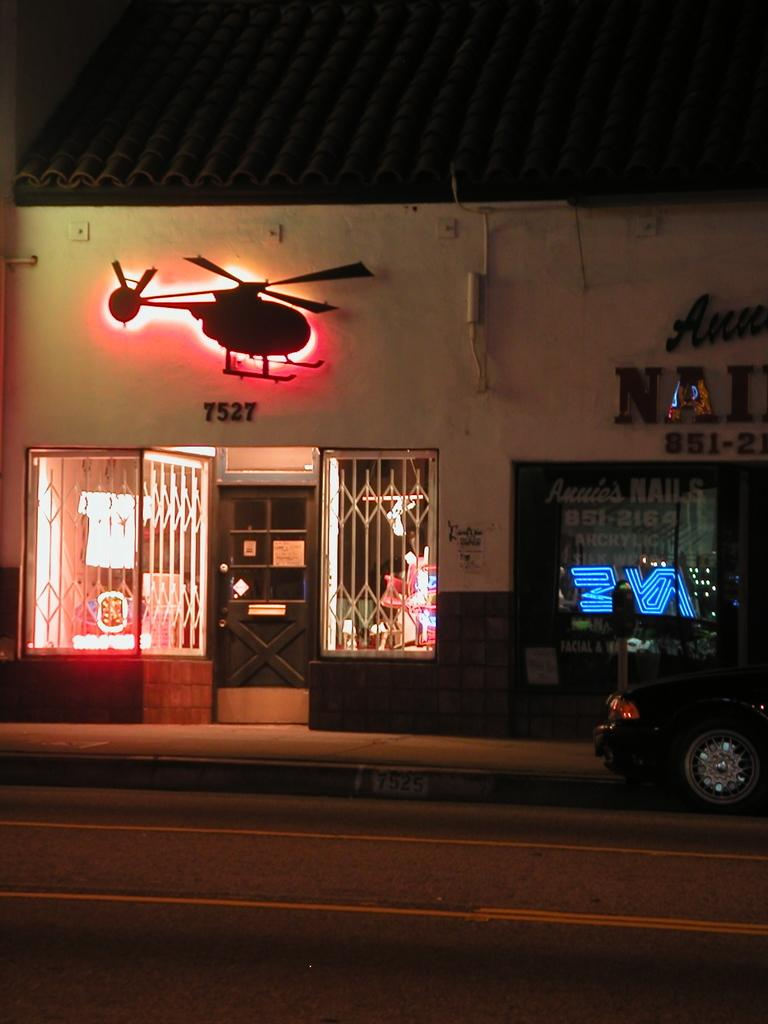What type of structure is present in the image? There is a building in the image. Where is the main entrance to the building located? There is a door in the middle of the building. What can be seen on the right side of the image? There is a car on the right side of the image. What architectural feature is present on the left side of the image? There are grilles on the left side of the image. What is written or displayed on the right side of the image? There is some text visible on the right side of the image. What type of leather is used to make the basketball in the image? There is no basketball present in the image. How does the fire burn on the left side of the image? There is no fire or burning object present in the image. 